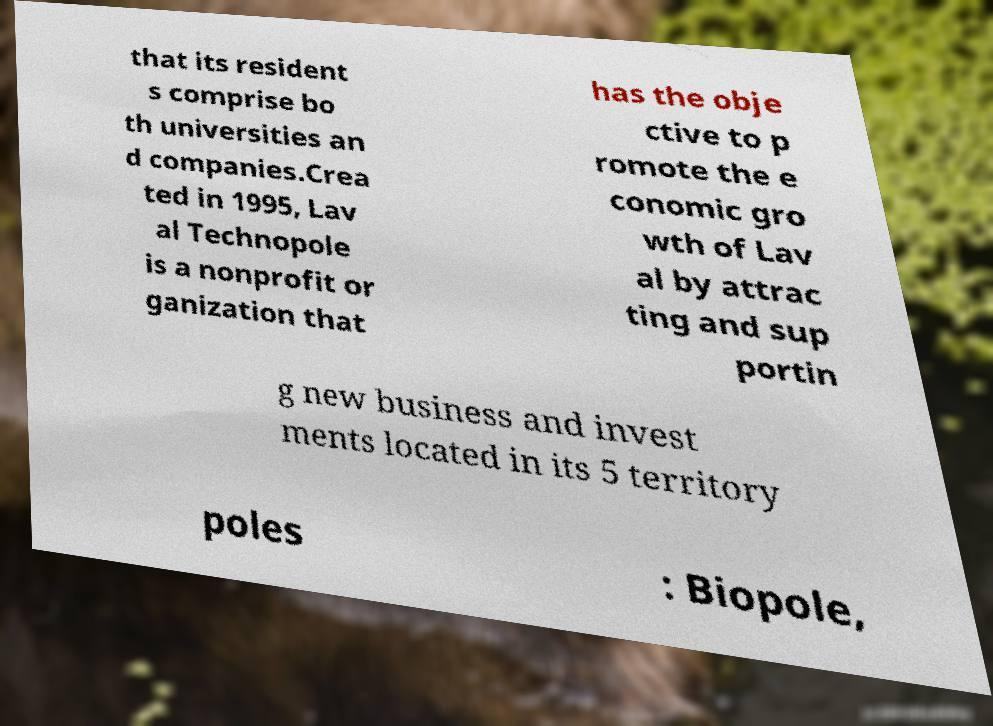There's text embedded in this image that I need extracted. Can you transcribe it verbatim? that its resident s comprise bo th universities an d companies.Crea ted in 1995, Lav al Technopole is a nonprofit or ganization that has the obje ctive to p romote the e conomic gro wth of Lav al by attrac ting and sup portin g new business and invest ments located in its 5 territory poles : Biopole, 